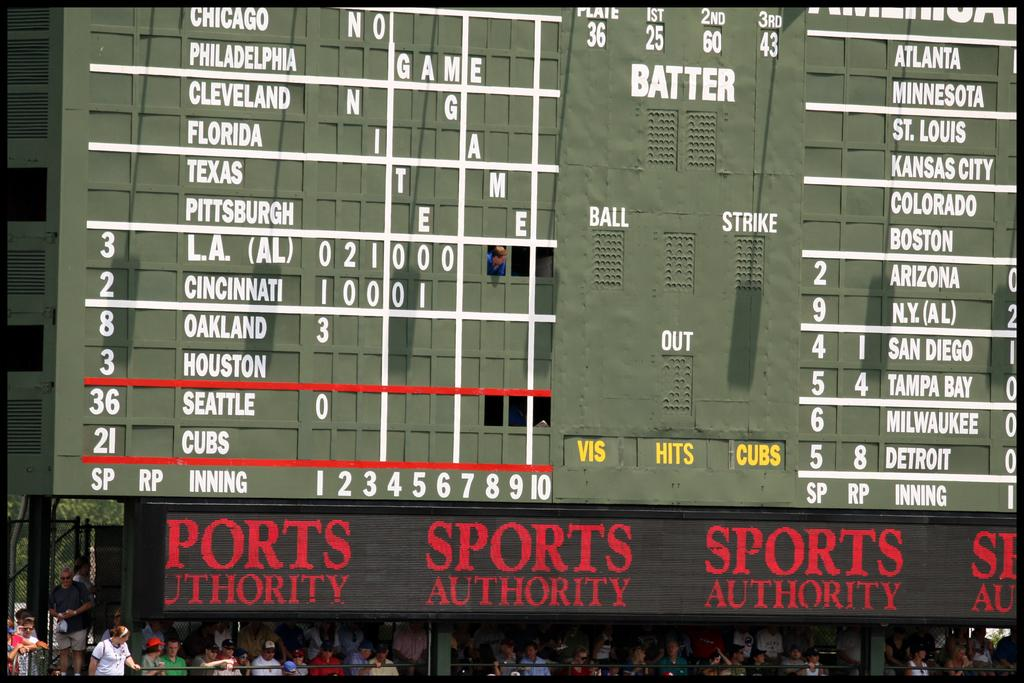Provide a one-sentence caption for the provided image. Sports authority game that include baseball teams scores. 